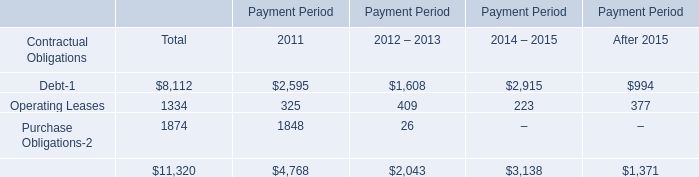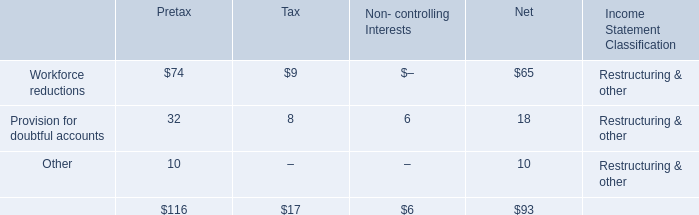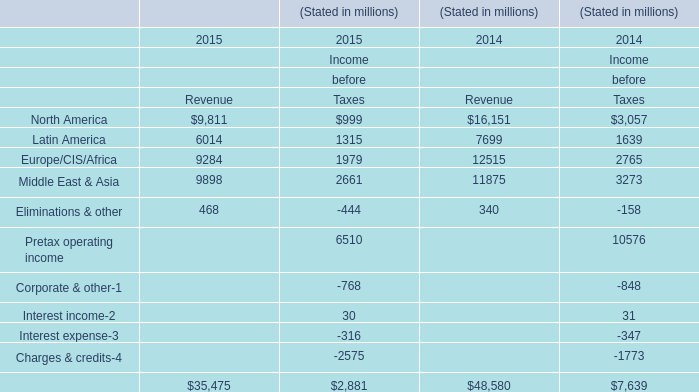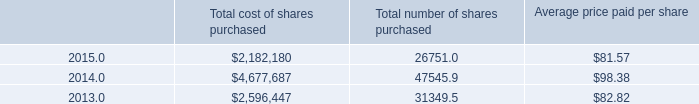What is the ratio of Eliminations & other for Revenue to the total in 2014? 
Computations: (340 / 48580)
Answer: 0.007. 